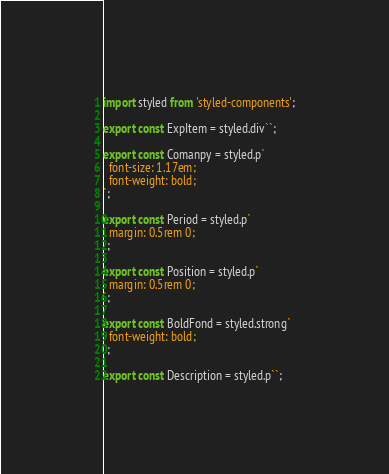Convert code to text. <code><loc_0><loc_0><loc_500><loc_500><_JavaScript_>import styled from 'styled-components';

export const ExpItem = styled.div``;

export const Comanpy = styled.p`
  font-size: 1.17em;
  font-weight: bold;
`;

export const Period = styled.p`
  margin: 0.5rem 0;
`;

export const Position = styled.p`
  margin: 0.5rem 0;
`;

export const BoldFond = styled.strong`
  font-weight: bold;
`;

export const Description = styled.p``;
</code> 